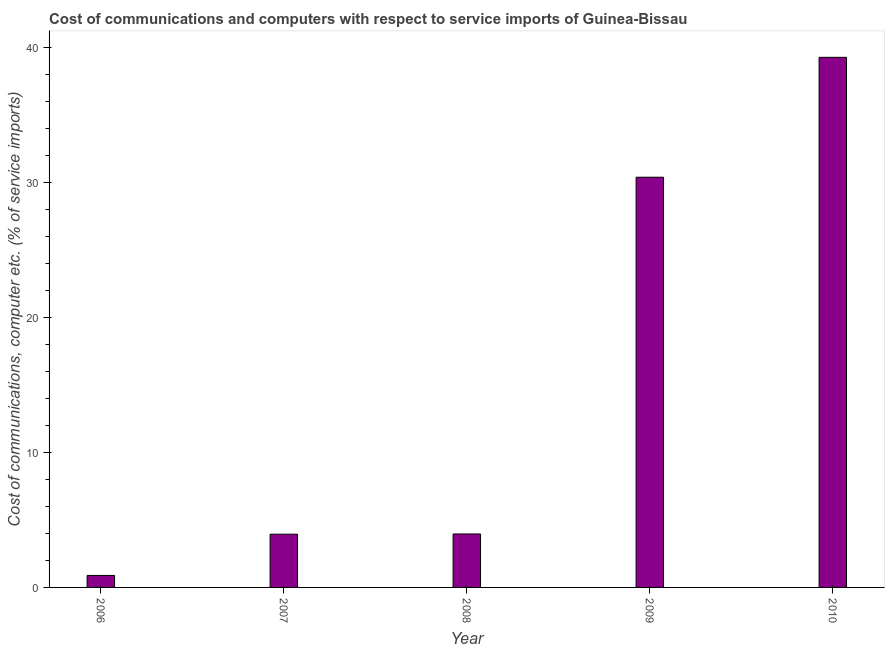Does the graph contain grids?
Offer a very short reply. No. What is the title of the graph?
Your response must be concise. Cost of communications and computers with respect to service imports of Guinea-Bissau. What is the label or title of the X-axis?
Ensure brevity in your answer.  Year. What is the label or title of the Y-axis?
Your answer should be very brief. Cost of communications, computer etc. (% of service imports). What is the cost of communications and computer in 2009?
Provide a short and direct response. 30.4. Across all years, what is the maximum cost of communications and computer?
Ensure brevity in your answer.  39.29. Across all years, what is the minimum cost of communications and computer?
Make the answer very short. 0.89. In which year was the cost of communications and computer minimum?
Your response must be concise. 2006. What is the sum of the cost of communications and computer?
Make the answer very short. 78.48. What is the difference between the cost of communications and computer in 2008 and 2010?
Make the answer very short. -35.33. What is the average cost of communications and computer per year?
Make the answer very short. 15.7. What is the median cost of communications and computer?
Provide a short and direct response. 3.96. In how many years, is the cost of communications and computer greater than 2 %?
Your answer should be very brief. 4. Do a majority of the years between 2009 and 2010 (inclusive) have cost of communications and computer greater than 2 %?
Offer a terse response. Yes. What is the ratio of the cost of communications and computer in 2009 to that in 2010?
Provide a short and direct response. 0.77. Is the cost of communications and computer in 2007 less than that in 2008?
Offer a very short reply. Yes. What is the difference between the highest and the second highest cost of communications and computer?
Offer a terse response. 8.89. Is the sum of the cost of communications and computer in 2008 and 2010 greater than the maximum cost of communications and computer across all years?
Offer a very short reply. Yes. What is the difference between the highest and the lowest cost of communications and computer?
Offer a very short reply. 38.4. In how many years, is the cost of communications and computer greater than the average cost of communications and computer taken over all years?
Give a very brief answer. 2. How many years are there in the graph?
Make the answer very short. 5. Are the values on the major ticks of Y-axis written in scientific E-notation?
Your response must be concise. No. What is the Cost of communications, computer etc. (% of service imports) in 2006?
Give a very brief answer. 0.89. What is the Cost of communications, computer etc. (% of service imports) in 2007?
Keep it short and to the point. 3.95. What is the Cost of communications, computer etc. (% of service imports) in 2008?
Your response must be concise. 3.96. What is the Cost of communications, computer etc. (% of service imports) of 2009?
Provide a succinct answer. 30.4. What is the Cost of communications, computer etc. (% of service imports) of 2010?
Provide a short and direct response. 39.29. What is the difference between the Cost of communications, computer etc. (% of service imports) in 2006 and 2007?
Offer a terse response. -3.06. What is the difference between the Cost of communications, computer etc. (% of service imports) in 2006 and 2008?
Make the answer very short. -3.07. What is the difference between the Cost of communications, computer etc. (% of service imports) in 2006 and 2009?
Offer a terse response. -29.51. What is the difference between the Cost of communications, computer etc. (% of service imports) in 2006 and 2010?
Offer a very short reply. -38.4. What is the difference between the Cost of communications, computer etc. (% of service imports) in 2007 and 2008?
Make the answer very short. -0.02. What is the difference between the Cost of communications, computer etc. (% of service imports) in 2007 and 2009?
Keep it short and to the point. -26.46. What is the difference between the Cost of communications, computer etc. (% of service imports) in 2007 and 2010?
Your answer should be compact. -35.34. What is the difference between the Cost of communications, computer etc. (% of service imports) in 2008 and 2009?
Provide a succinct answer. -26.44. What is the difference between the Cost of communications, computer etc. (% of service imports) in 2008 and 2010?
Your answer should be very brief. -35.32. What is the difference between the Cost of communications, computer etc. (% of service imports) in 2009 and 2010?
Make the answer very short. -8.89. What is the ratio of the Cost of communications, computer etc. (% of service imports) in 2006 to that in 2007?
Make the answer very short. 0.23. What is the ratio of the Cost of communications, computer etc. (% of service imports) in 2006 to that in 2008?
Make the answer very short. 0.22. What is the ratio of the Cost of communications, computer etc. (% of service imports) in 2006 to that in 2009?
Provide a succinct answer. 0.03. What is the ratio of the Cost of communications, computer etc. (% of service imports) in 2006 to that in 2010?
Provide a succinct answer. 0.02. What is the ratio of the Cost of communications, computer etc. (% of service imports) in 2007 to that in 2009?
Offer a very short reply. 0.13. What is the ratio of the Cost of communications, computer etc. (% of service imports) in 2007 to that in 2010?
Give a very brief answer. 0.1. What is the ratio of the Cost of communications, computer etc. (% of service imports) in 2008 to that in 2009?
Provide a succinct answer. 0.13. What is the ratio of the Cost of communications, computer etc. (% of service imports) in 2008 to that in 2010?
Your answer should be compact. 0.1. What is the ratio of the Cost of communications, computer etc. (% of service imports) in 2009 to that in 2010?
Keep it short and to the point. 0.77. 